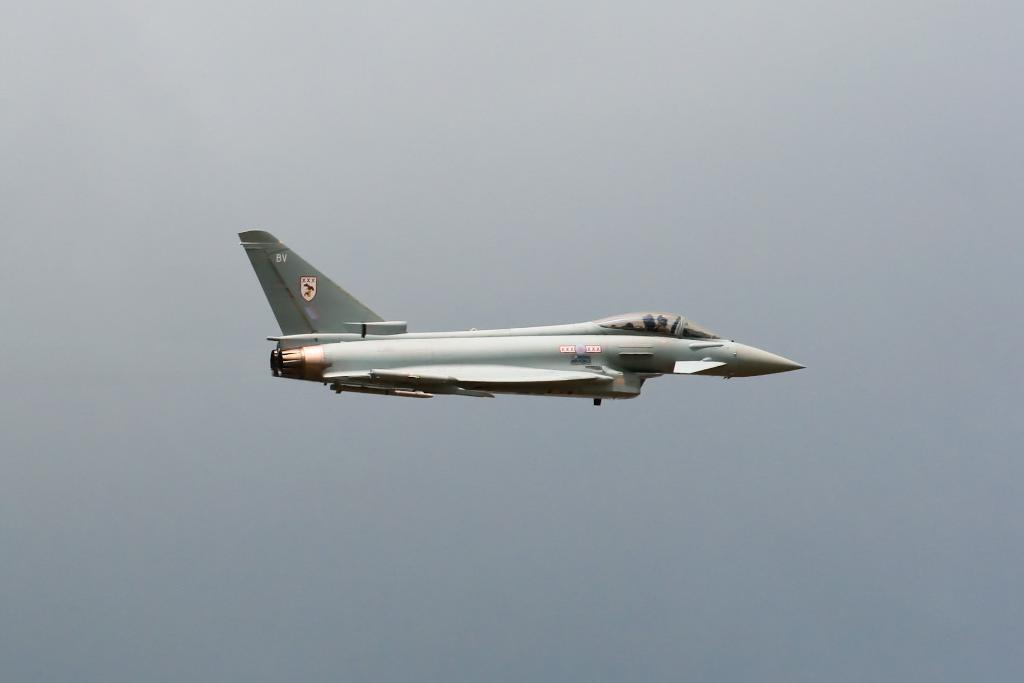What is the main subject of the image? The main subject of the image is a fighter jet. Where is the fighter jet located in the image? The fighter jet is in the air. What can be seen in the background of the image? The sky is visible in the image. How would you describe the weather based on the image? The sky appears to be cloudy, suggesting partly cloudy weather. What type of ship can be seen sailing in the image? There is no ship present in the image; it features a fighter jet in the air. Can you tell me how many beetles are crawling on the fighter jet in the image? There are no beetles present on the fighter jet in the image. 